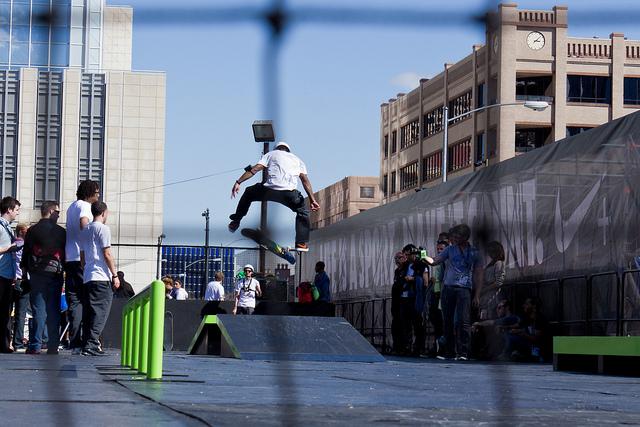Is the skateboarder touching his board?
Concise answer only. No. What color is the man's t-shirt?
Keep it brief. White. Is this man skateboarding?
Concise answer only. Yes. 